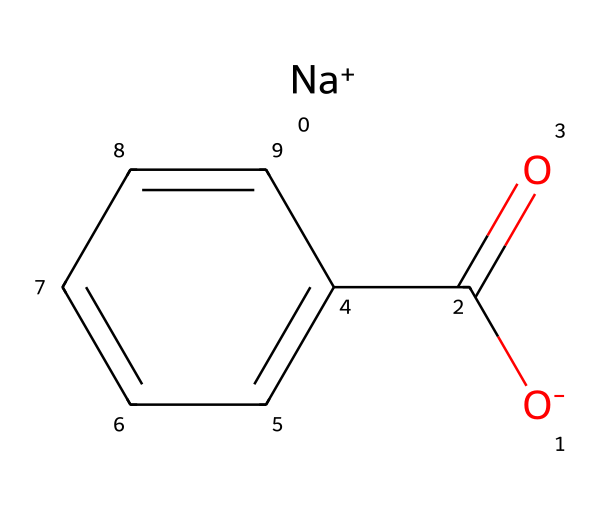What is the molecular formula of sodium benzoate? The SMILES representation indicates that sodium benzoate consists of one sodium (Na) atom, and the rest is derived from the benzoate ion, which has a structure of C7H5O2. Therefore, the overall molecular formula is C7H5NaO2.
Answer: C7H5NaO2 How many carbon atoms are in sodium benzoate? The SMILES shows that the structure has a benzene ring (C6) and a carboxylate group (-COO), which contributes one additional carbon atom. Thus, there are 7 carbon atoms.
Answer: 7 What type of ion is sodium in sodium benzoate? The SMILES representation shows sodium as "[Na+]", indicating that it is a cation with a positive charge.
Answer: cation How many hydrogen atoms are present in sodium benzoate? From the molecular formula C7H5NaO2, there are 5 hydrogen atoms in sodium benzoate as indicated by the H in the formula.
Answer: 5 What functional group is present in sodium benzoate? Analyzing the structure, the presence of the -COO group is indicative of a carboxylate functional group, which is characteristic of sodium benzoate.
Answer: carboxylate Why does sodium benzoate act as a preservative? Sodium benzoate inhibits microbial growth by creating an acidic environment when dissolved in solution, which is facilitated by its carboxylate group that reacts with protons in aqueous environments, effectively lowering the pH and preventing spoilage.
Answer: inhibits microbial growth 